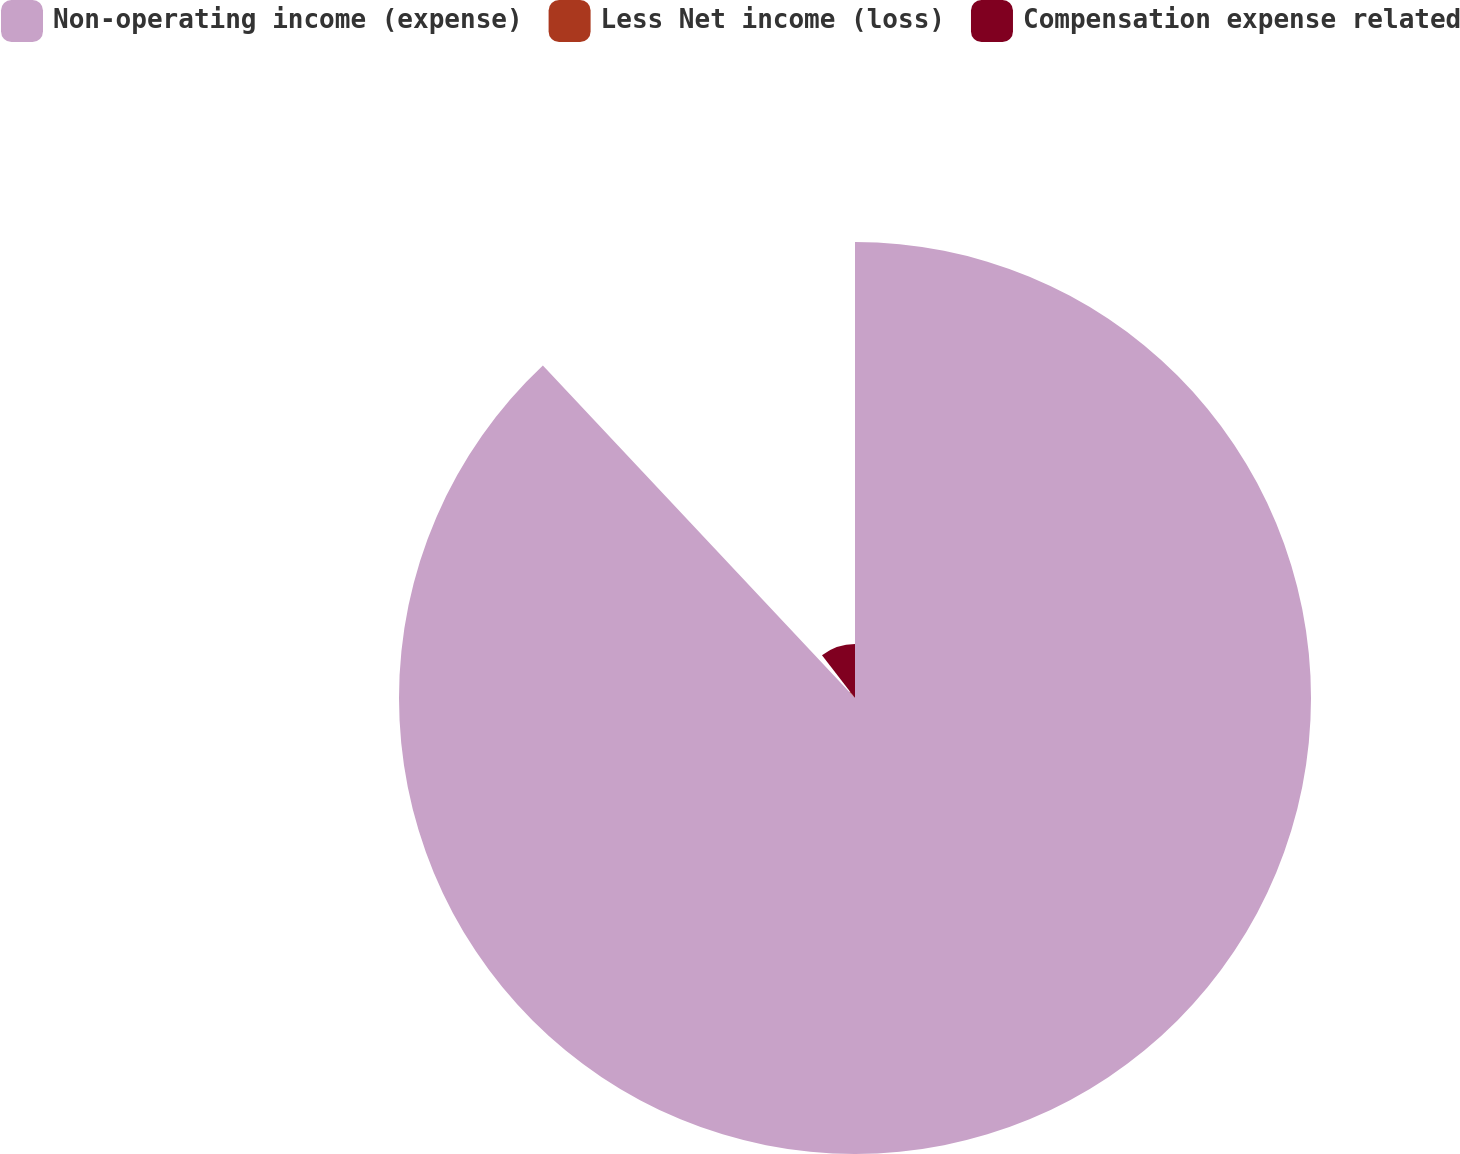Convert chart. <chart><loc_0><loc_0><loc_500><loc_500><pie_chart><fcel>Non-operating income (expense)<fcel>Less Net income (loss)<fcel>Compensation expense related<nl><fcel>88.01%<fcel>1.56%<fcel>10.44%<nl></chart> 